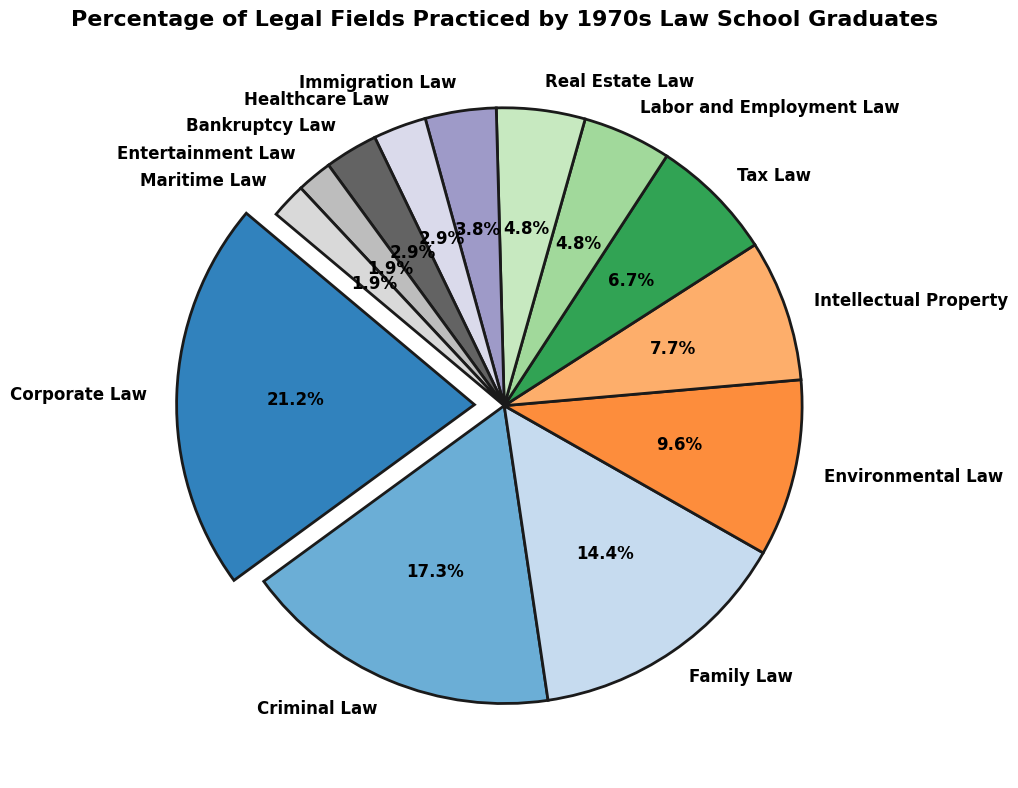Which legal field is the most practiced among the 1970s law school graduates? By looking at the pie chart and identifying the slice with the largest percentage, we see that Corporate Law has the highest percentage.
Answer: Corporate Law Which two legal fields share the smallest percentage of practices? By observing the slices with the smallest percentages, we notice that Entertainment Law and Maritime Law both have the smallest percentages.
Answer: Entertainment Law and Maritime Law What is the combined percentage of Family Law and Criminal Law practices? The percentage of Criminal Law is 18%, and Family Law is 15%. Adding these together, we get 18% + 15% = 33%.
Answer: 33% Does Corporate Law have a higher percentage than Environmental Law and Intellectual Property combined? The percentage of Corporate Law is 22%. The combined percentage for Environmental Law (10%) and Intellectual Property (8%) is 10% + 8% = 18%. Since 22% is greater than 18%, the answer is yes.
Answer: Yes Which legal field, Environmental Law or Immigration Law, is practiced more by the graduates? We compare the percentages and see that Environmental Law at 10% is greater than Immigration Law at 4%.
Answer: Environmental Law How many more percentage points is Corporate Law practiced compared to Tax Law? Corporate Law is practiced at 22%, and Tax Law is practiced at 7%. The difference is 22% - 7% = 15 percentage points.
Answer: 15 percentage points What is the total percentage for all legal fields that have less than 5% practice? Add the percentages for Labor and Employment Law (5%), Real Estate Law (5%), Immigration Law (4%), Healthcare Law (3%), Bankruptcy Law (3%), Entertainment Law (2%), and Maritime Law (2%). The sum is 5% + 5% + 4% + 3% + 3% + 2% + 2% = 24%.
Answer: 24% Is the slice representing Criminal Law a different color compared to Family Law? By observing the color of the slices representing Criminal Law and Family Law in the pie chart, we can verify that they are different colors.
Answer: Yes If you combine the percentages of Tax Law and Labor and Employment Law, would the sum exceed that of Intellectual Property? Tax Law is 7%, and Labor and Employment Law is 5%. Combined, they total 7% + 5% = 12%, which is greater than Intellectual Property's 8%.
Answer: Yes Is Family Law practiced equal to or more than Healthcare Law, Bankruptcy Law, and Immigration Law combined? Family Law is practiced at 15%. The combined percentage for Healthcare Law (3%), Bankruptcy Law (3%), and Immigration Law (4%) is 3% + 3% + 4% = 10%. Since 15% is greater than 10%, Family Law is practiced more.
Answer: More 